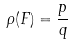<formula> <loc_0><loc_0><loc_500><loc_500>\rho ( F ) = \frac { p } { q }</formula> 